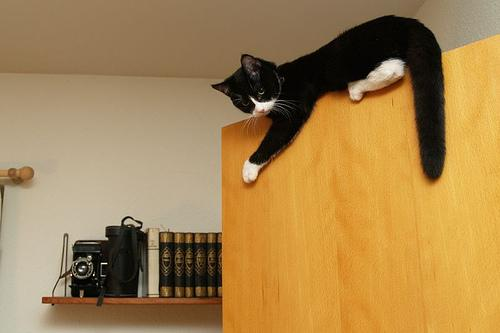What old device can be seen on the left end of the shelf? camera 